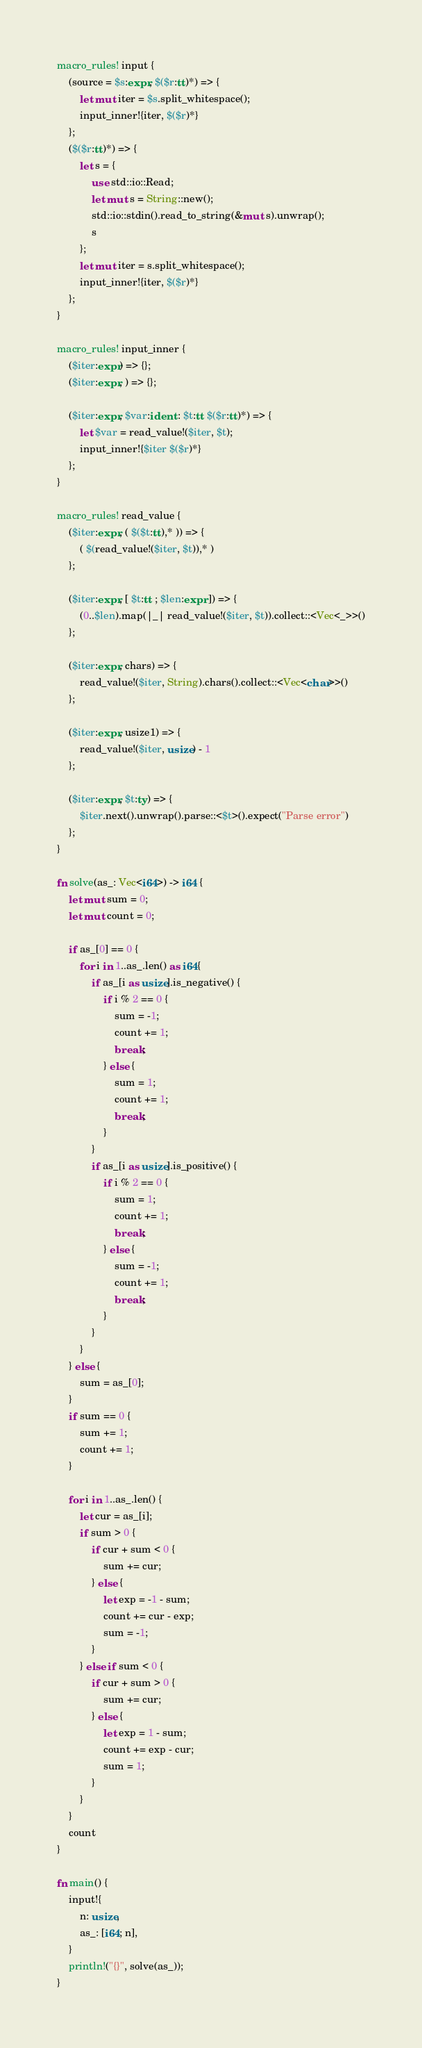<code> <loc_0><loc_0><loc_500><loc_500><_Rust_>macro_rules! input {
    (source = $s:expr, $($r:tt)*) => {
        let mut iter = $s.split_whitespace();
        input_inner!{iter, $($r)*}
    };
    ($($r:tt)*) => {
        let s = {
            use std::io::Read;
            let mut s = String::new();
            std::io::stdin().read_to_string(&mut s).unwrap();
            s
        };
        let mut iter = s.split_whitespace();
        input_inner!{iter, $($r)*}
    };
}

macro_rules! input_inner {
    ($iter:expr) => {};
    ($iter:expr, ) => {};

    ($iter:expr, $var:ident : $t:tt $($r:tt)*) => {
        let $var = read_value!($iter, $t);
        input_inner!{$iter $($r)*}
    };
}

macro_rules! read_value {
    ($iter:expr, ( $($t:tt),* )) => {
        ( $(read_value!($iter, $t)),* )
    };

    ($iter:expr, [ $t:tt ; $len:expr ]) => {
        (0..$len).map(|_| read_value!($iter, $t)).collect::<Vec<_>>()
    };

    ($iter:expr, chars) => {
        read_value!($iter, String).chars().collect::<Vec<char>>()
    };

    ($iter:expr, usize1) => {
        read_value!($iter, usize) - 1
    };

    ($iter:expr, $t:ty) => {
        $iter.next().unwrap().parse::<$t>().expect("Parse error")
    };
}

fn solve(as_: Vec<i64>) -> i64 {
    let mut sum = 0;
    let mut count = 0;

    if as_[0] == 0 {
        for i in 1..as_.len() as i64{
            if as_[i as usize].is_negative() {
                if i % 2 == 0 {
                    sum = -1;
                    count += 1;
                    break;
                } else {
                    sum = 1;
                    count += 1;
                    break;
                }
            }
            if as_[i as usize].is_positive() {
                if i % 2 == 0 {
                    sum = 1;
                    count += 1;
                    break;
                } else {
                    sum = -1;
                    count += 1;
                    break;
                }
            }
        }
    } else {
        sum = as_[0];
    }
    if sum == 0 {
        sum += 1;
        count += 1;
    }

    for i in 1..as_.len() {
        let cur = as_[i];
        if sum > 0 {
            if cur + sum < 0 {
                sum += cur;
            } else {
                let exp = -1 - sum;
                count += cur - exp;
                sum = -1;
            }
        } else if sum < 0 {
            if cur + sum > 0 {
                sum += cur;
            } else {
                let exp = 1 - sum;
                count += exp - cur;
                sum = 1;
            }
        }
    }
    count
}

fn main() {
    input!{
        n: usize,
        as_: [i64; n],
    }
    println!("{}", solve(as_));
}
</code> 